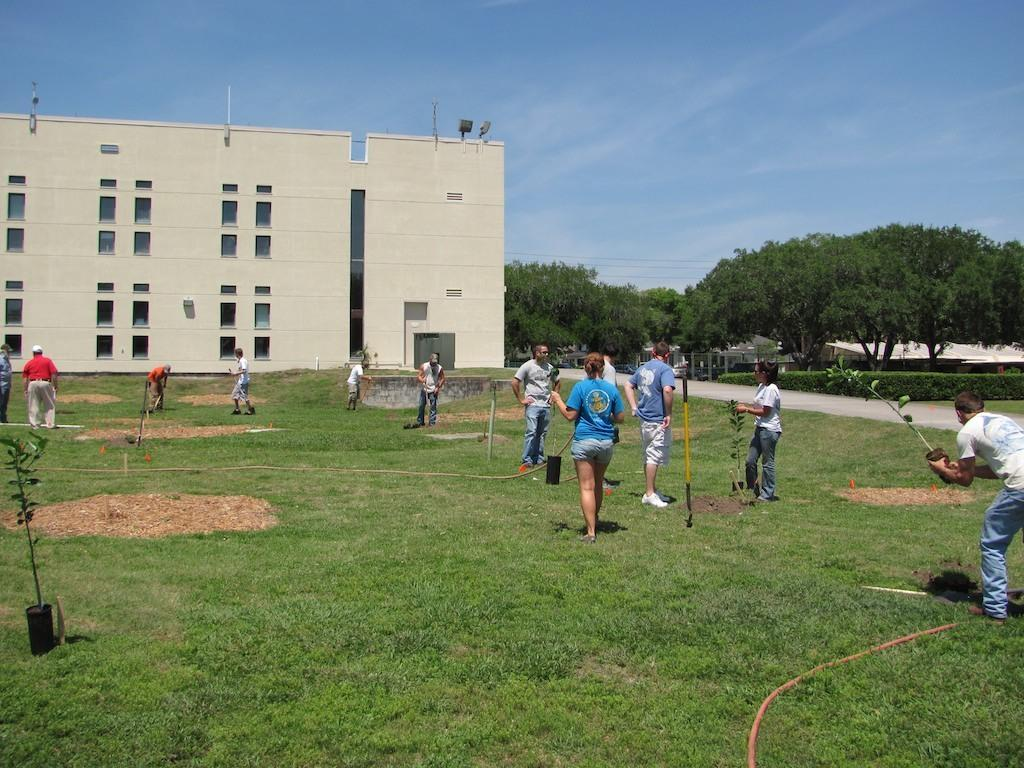What type of structure is present in the image? There is a building in the image. What feature can be seen on the building? The building has windows. What type of natural environment is visible in the image? There are trees, grass, and plants in the image. What part of the sky is visible in the image? The sky is visible in the image. Are there any living beings in the image? Yes, there are people in the image. What are some people doing in the image? Some people are holding something. What type of smell can be detected in the image? There is no information about smells in the image, so it cannot be determined. 